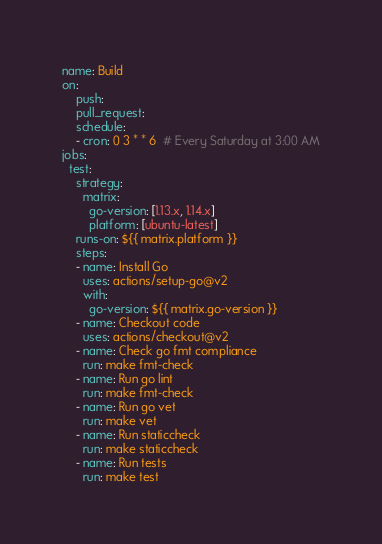Convert code to text. <code><loc_0><loc_0><loc_500><loc_500><_YAML_>name: Build
on:
    push:
    pull_request:
    schedule:
    - cron: 0 3 * * 6  # Every Saturday at 3:00 AM
jobs:
  test:
    strategy:
      matrix:
        go-version: [1.13.x, 1.14.x]
        platform: [ubuntu-latest]
    runs-on: ${{ matrix.platform }}
    steps:
    - name: Install Go
      uses: actions/setup-go@v2
      with:
        go-version: ${{ matrix.go-version }}
    - name: Checkout code
      uses: actions/checkout@v2
    - name: Check go fmt compliance
      run: make fmt-check
    - name: Run go lint
      run: make fmt-check
    - name: Run go vet
      run: make vet
    - name: Run staticcheck
      run: make staticcheck
    - name: Run tests
      run: make test
</code> 